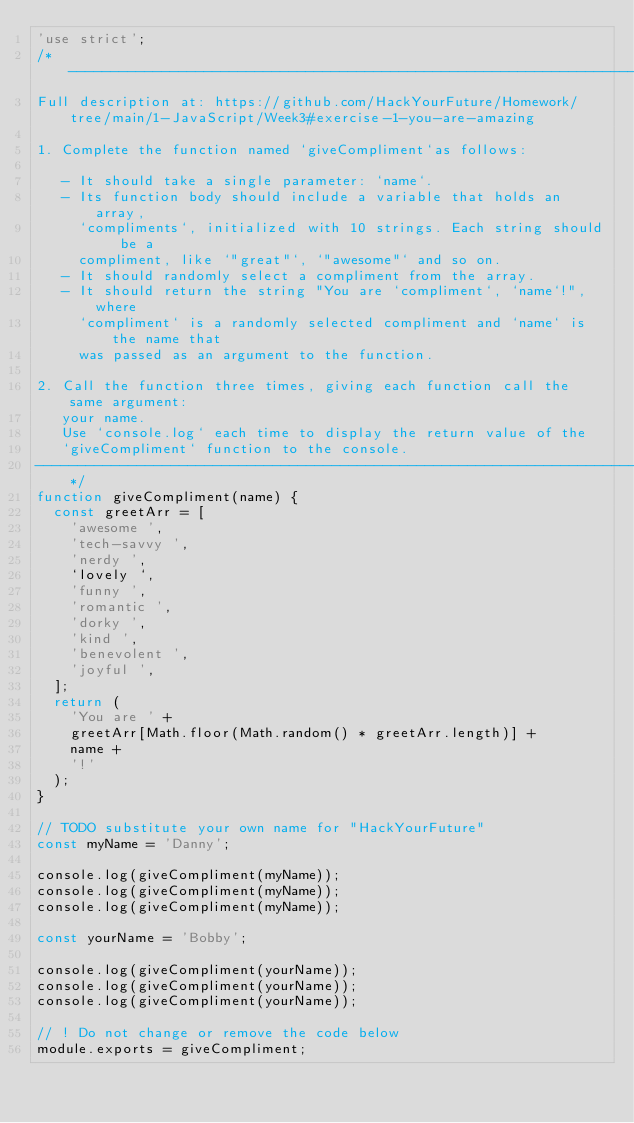<code> <loc_0><loc_0><loc_500><loc_500><_JavaScript_>'use strict';
/* -----------------------------------------------------------------------------
Full description at: https://github.com/HackYourFuture/Homework/tree/main/1-JavaScript/Week3#exercise-1-you-are-amazing

1. Complete the function named `giveCompliment`as follows:

   - It should take a single parameter: `name`.
   - Its function body should include a variable that holds an array,
     `compliments`, initialized with 10 strings. Each string should be a
     compliment, like `"great"`, `"awesome"` and so on.
   - It should randomly select a compliment from the array.
   - It should return the string "You are `compliment`, `name`!", where
     `compliment` is a randomly selected compliment and `name` is the name that
     was passed as an argument to the function.

2. Call the function three times, giving each function call the same argument:
   your name.
   Use `console.log` each time to display the return value of the
   `giveCompliment` function to the console.
-----------------------------------------------------------------------------*/
function giveCompliment(name) {
  const greetArr = [
    'awesome ',
    'tech-savvy ',
    'nerdy ',
    `lovely `,
    'funny ',
    'romantic ',
    'dorky ',
    'kind ',
    'benevolent ',
    'joyful ',
  ];
  return (
    'You are ' +
    greetArr[Math.floor(Math.random() * greetArr.length)] +
    name +
    '!'
  );
}

// TODO substitute your own name for "HackYourFuture"
const myName = 'Danny';

console.log(giveCompliment(myName));
console.log(giveCompliment(myName));
console.log(giveCompliment(myName));

const yourName = 'Bobby';

console.log(giveCompliment(yourName));
console.log(giveCompliment(yourName));
console.log(giveCompliment(yourName));

// ! Do not change or remove the code below
module.exports = giveCompliment;
</code> 